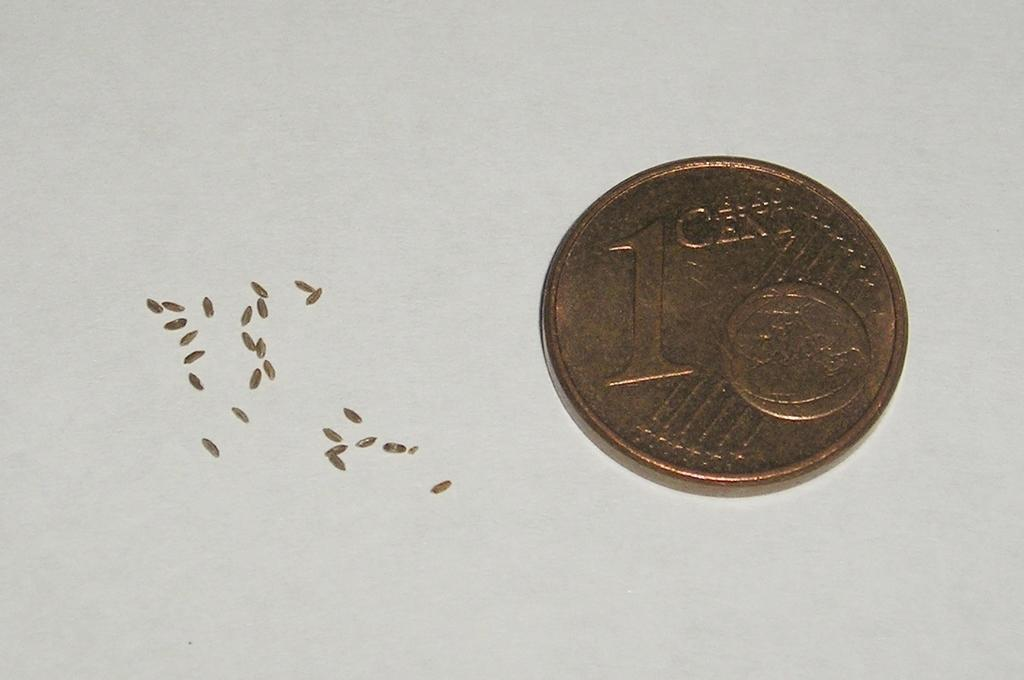<image>
Describe the image concisely. A one cent coin sits to the right of some metallic colored metal shavings. 